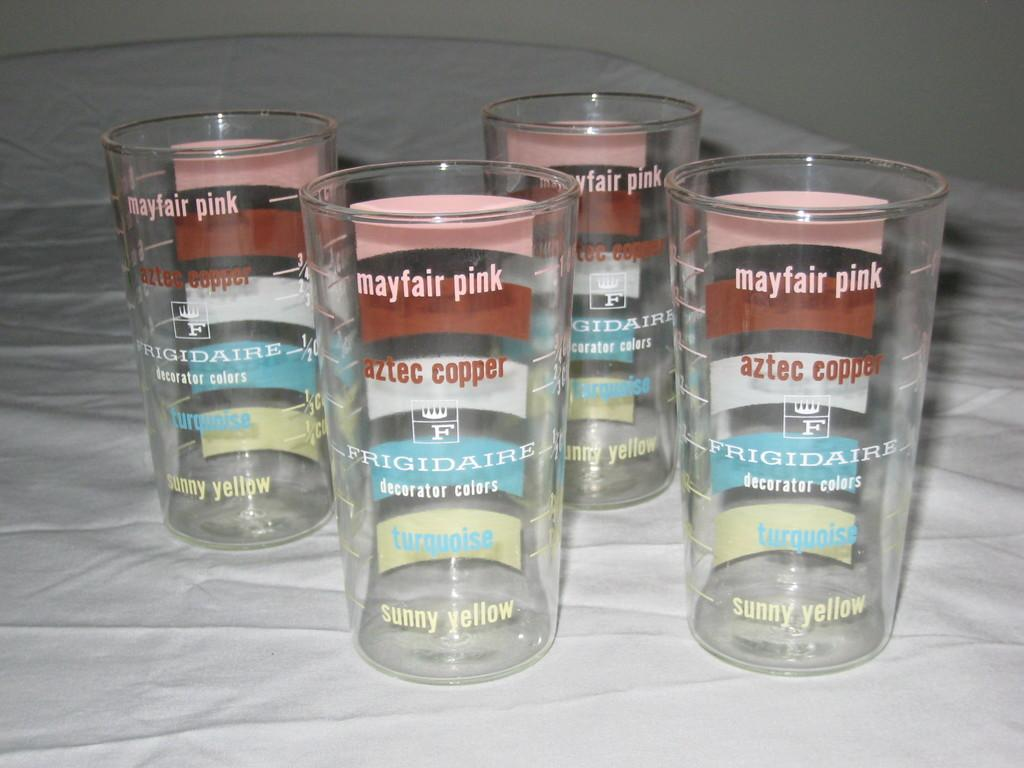<image>
Offer a succinct explanation of the picture presented. Four cup that say "Mayfair pink" are sitting on a white cloth. 